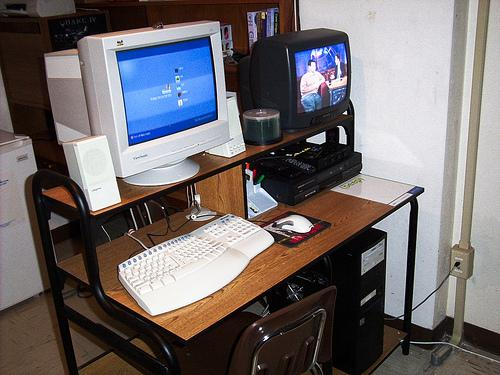Question: where was this picture taken?
Choices:
A. In the library.
B. In the living room.
C. In a home office.
D. In the kitchen.
Answer with the letter. Answer: C Question: what color is the computer's mouse?
Choices:
A. Blue.
B. Black.
C. Red.
D. White.
Answer with the letter. Answer: D Question: how many dinosaurs are in the picture?
Choices:
A. One.
B. Zero.
C. Two.
D. Three.
Answer with the letter. Answer: B Question: how many people are eating donuts?
Choices:
A. One.
B. Zero.
C. Two.
D. Three.
Answer with the letter. Answer: B 